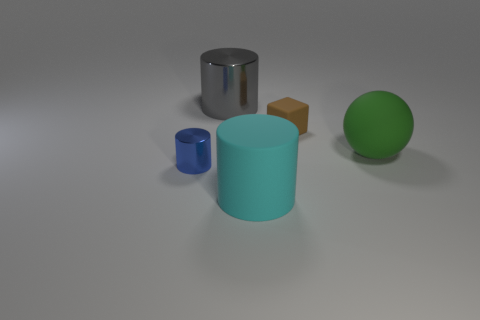Subtract all brown cylinders. Subtract all purple balls. How many cylinders are left? 3 Add 2 big gray shiny cylinders. How many objects exist? 7 Subtract all cylinders. How many objects are left? 2 Add 1 large yellow cylinders. How many large yellow cylinders exist? 1 Subtract 0 yellow cubes. How many objects are left? 5 Subtract all large brown rubber objects. Subtract all green things. How many objects are left? 4 Add 4 small blue metal objects. How many small blue metal objects are left? 5 